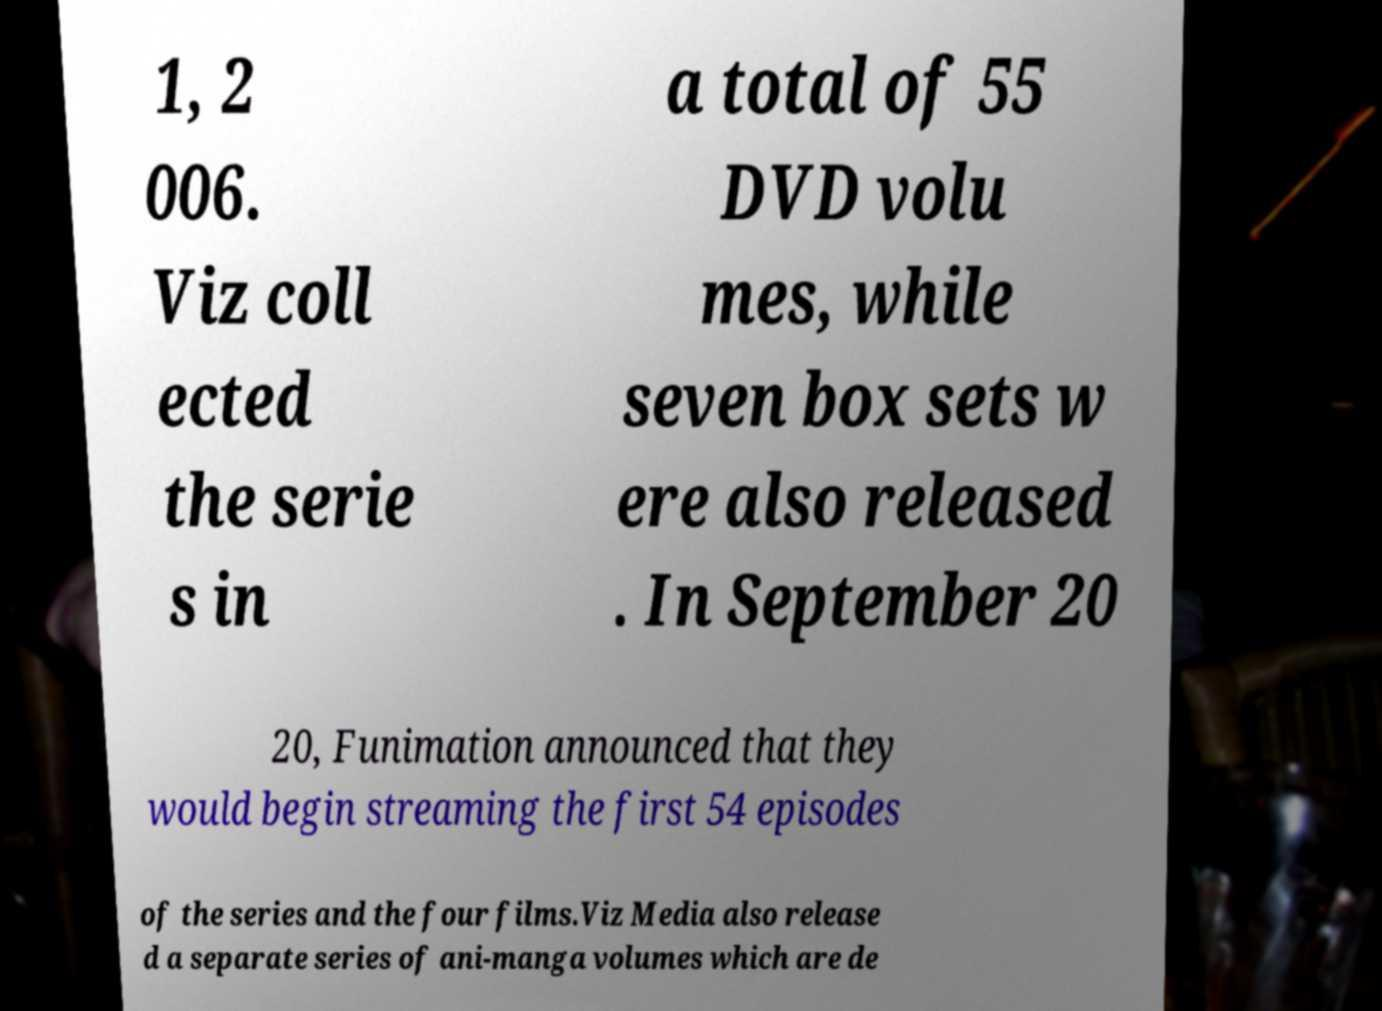What messages or text are displayed in this image? I need them in a readable, typed format. 1, 2 006. Viz coll ected the serie s in a total of 55 DVD volu mes, while seven box sets w ere also released . In September 20 20, Funimation announced that they would begin streaming the first 54 episodes of the series and the four films.Viz Media also release d a separate series of ani-manga volumes which are de 